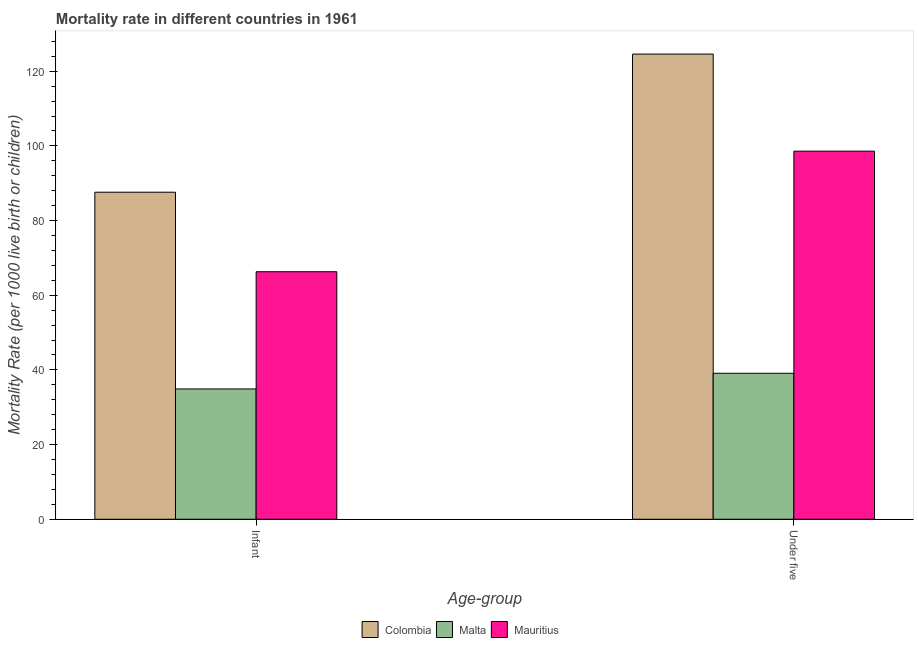How many groups of bars are there?
Your response must be concise. 2. Are the number of bars per tick equal to the number of legend labels?
Provide a short and direct response. Yes. How many bars are there on the 2nd tick from the left?
Offer a terse response. 3. What is the label of the 2nd group of bars from the left?
Your response must be concise. Under five. What is the infant mortality rate in Colombia?
Your answer should be very brief. 87.6. Across all countries, what is the maximum under-5 mortality rate?
Provide a short and direct response. 124.6. Across all countries, what is the minimum under-5 mortality rate?
Your response must be concise. 39.1. In which country was the infant mortality rate minimum?
Your answer should be compact. Malta. What is the total under-5 mortality rate in the graph?
Offer a terse response. 262.3. What is the difference between the infant mortality rate in Mauritius and that in Colombia?
Your response must be concise. -21.3. What is the difference between the infant mortality rate in Malta and the under-5 mortality rate in Mauritius?
Offer a very short reply. -63.7. What is the average under-5 mortality rate per country?
Your answer should be compact. 87.43. What is the difference between the infant mortality rate and under-5 mortality rate in Mauritius?
Offer a very short reply. -32.3. In how many countries, is the infant mortality rate greater than 80 ?
Provide a short and direct response. 1. What is the ratio of the under-5 mortality rate in Malta to that in Colombia?
Give a very brief answer. 0.31. Is the under-5 mortality rate in Colombia less than that in Malta?
Offer a very short reply. No. What does the 3rd bar from the right in Under five represents?
Keep it short and to the point. Colombia. How many bars are there?
Offer a terse response. 6. Does the graph contain any zero values?
Your answer should be compact. No. Where does the legend appear in the graph?
Your answer should be very brief. Bottom center. How many legend labels are there?
Your response must be concise. 3. How are the legend labels stacked?
Your response must be concise. Horizontal. What is the title of the graph?
Provide a succinct answer. Mortality rate in different countries in 1961. What is the label or title of the X-axis?
Ensure brevity in your answer.  Age-group. What is the label or title of the Y-axis?
Offer a terse response. Mortality Rate (per 1000 live birth or children). What is the Mortality Rate (per 1000 live birth or children) in Colombia in Infant?
Your response must be concise. 87.6. What is the Mortality Rate (per 1000 live birth or children) of Malta in Infant?
Keep it short and to the point. 34.9. What is the Mortality Rate (per 1000 live birth or children) in Mauritius in Infant?
Keep it short and to the point. 66.3. What is the Mortality Rate (per 1000 live birth or children) in Colombia in Under five?
Your answer should be compact. 124.6. What is the Mortality Rate (per 1000 live birth or children) in Malta in Under five?
Provide a succinct answer. 39.1. What is the Mortality Rate (per 1000 live birth or children) of Mauritius in Under five?
Provide a short and direct response. 98.6. Across all Age-group, what is the maximum Mortality Rate (per 1000 live birth or children) in Colombia?
Your response must be concise. 124.6. Across all Age-group, what is the maximum Mortality Rate (per 1000 live birth or children) in Malta?
Your response must be concise. 39.1. Across all Age-group, what is the maximum Mortality Rate (per 1000 live birth or children) in Mauritius?
Provide a succinct answer. 98.6. Across all Age-group, what is the minimum Mortality Rate (per 1000 live birth or children) of Colombia?
Give a very brief answer. 87.6. Across all Age-group, what is the minimum Mortality Rate (per 1000 live birth or children) of Malta?
Offer a terse response. 34.9. Across all Age-group, what is the minimum Mortality Rate (per 1000 live birth or children) in Mauritius?
Provide a short and direct response. 66.3. What is the total Mortality Rate (per 1000 live birth or children) in Colombia in the graph?
Your answer should be very brief. 212.2. What is the total Mortality Rate (per 1000 live birth or children) of Mauritius in the graph?
Your answer should be compact. 164.9. What is the difference between the Mortality Rate (per 1000 live birth or children) of Colombia in Infant and that in Under five?
Your response must be concise. -37. What is the difference between the Mortality Rate (per 1000 live birth or children) of Malta in Infant and that in Under five?
Provide a succinct answer. -4.2. What is the difference between the Mortality Rate (per 1000 live birth or children) of Mauritius in Infant and that in Under five?
Ensure brevity in your answer.  -32.3. What is the difference between the Mortality Rate (per 1000 live birth or children) in Colombia in Infant and the Mortality Rate (per 1000 live birth or children) in Malta in Under five?
Make the answer very short. 48.5. What is the difference between the Mortality Rate (per 1000 live birth or children) of Malta in Infant and the Mortality Rate (per 1000 live birth or children) of Mauritius in Under five?
Ensure brevity in your answer.  -63.7. What is the average Mortality Rate (per 1000 live birth or children) of Colombia per Age-group?
Your answer should be compact. 106.1. What is the average Mortality Rate (per 1000 live birth or children) of Malta per Age-group?
Provide a short and direct response. 37. What is the average Mortality Rate (per 1000 live birth or children) of Mauritius per Age-group?
Your answer should be compact. 82.45. What is the difference between the Mortality Rate (per 1000 live birth or children) in Colombia and Mortality Rate (per 1000 live birth or children) in Malta in Infant?
Keep it short and to the point. 52.7. What is the difference between the Mortality Rate (per 1000 live birth or children) in Colombia and Mortality Rate (per 1000 live birth or children) in Mauritius in Infant?
Offer a terse response. 21.3. What is the difference between the Mortality Rate (per 1000 live birth or children) in Malta and Mortality Rate (per 1000 live birth or children) in Mauritius in Infant?
Offer a terse response. -31.4. What is the difference between the Mortality Rate (per 1000 live birth or children) of Colombia and Mortality Rate (per 1000 live birth or children) of Malta in Under five?
Provide a succinct answer. 85.5. What is the difference between the Mortality Rate (per 1000 live birth or children) in Colombia and Mortality Rate (per 1000 live birth or children) in Mauritius in Under five?
Keep it short and to the point. 26. What is the difference between the Mortality Rate (per 1000 live birth or children) of Malta and Mortality Rate (per 1000 live birth or children) of Mauritius in Under five?
Your response must be concise. -59.5. What is the ratio of the Mortality Rate (per 1000 live birth or children) in Colombia in Infant to that in Under five?
Keep it short and to the point. 0.7. What is the ratio of the Mortality Rate (per 1000 live birth or children) in Malta in Infant to that in Under five?
Your response must be concise. 0.89. What is the ratio of the Mortality Rate (per 1000 live birth or children) in Mauritius in Infant to that in Under five?
Ensure brevity in your answer.  0.67. What is the difference between the highest and the second highest Mortality Rate (per 1000 live birth or children) of Malta?
Make the answer very short. 4.2. What is the difference between the highest and the second highest Mortality Rate (per 1000 live birth or children) of Mauritius?
Ensure brevity in your answer.  32.3. What is the difference between the highest and the lowest Mortality Rate (per 1000 live birth or children) of Malta?
Offer a very short reply. 4.2. What is the difference between the highest and the lowest Mortality Rate (per 1000 live birth or children) of Mauritius?
Provide a succinct answer. 32.3. 